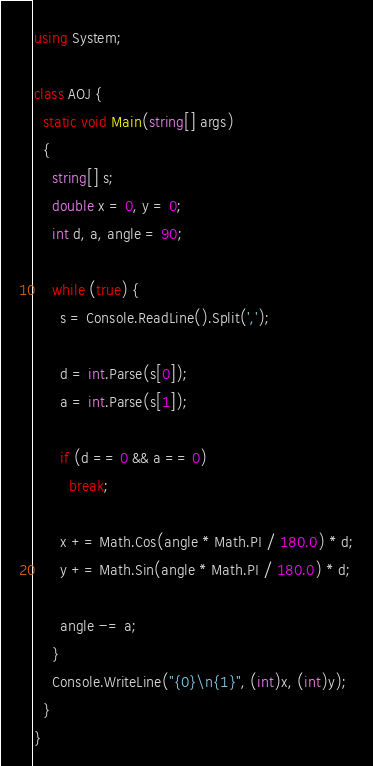<code> <loc_0><loc_0><loc_500><loc_500><_C#_>using System;

class AOJ {
  static void Main(string[] args)
  {
    string[] s;
    double x = 0, y = 0;
    int d, a, angle = 90;

    while (true) {
      s = Console.ReadLine().Split(',');

      d = int.Parse(s[0]);
      a = int.Parse(s[1]);

      if (d == 0 && a == 0)
        break;

      x += Math.Cos(angle * Math.PI / 180.0) * d;
      y += Math.Sin(angle * Math.PI / 180.0) * d;

      angle -= a;
    }
    Console.WriteLine("{0}\n{1}", (int)x, (int)y);
  }
}</code> 